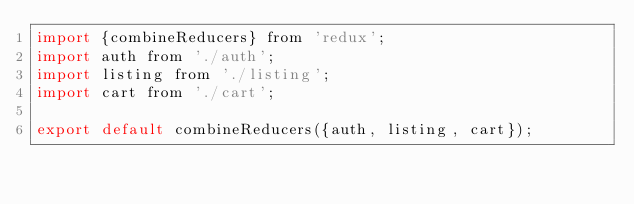Convert code to text. <code><loc_0><loc_0><loc_500><loc_500><_JavaScript_>import {combineReducers} from 'redux';
import auth from './auth';
import listing from './listing';
import cart from './cart';

export default combineReducers({auth, listing, cart});</code> 